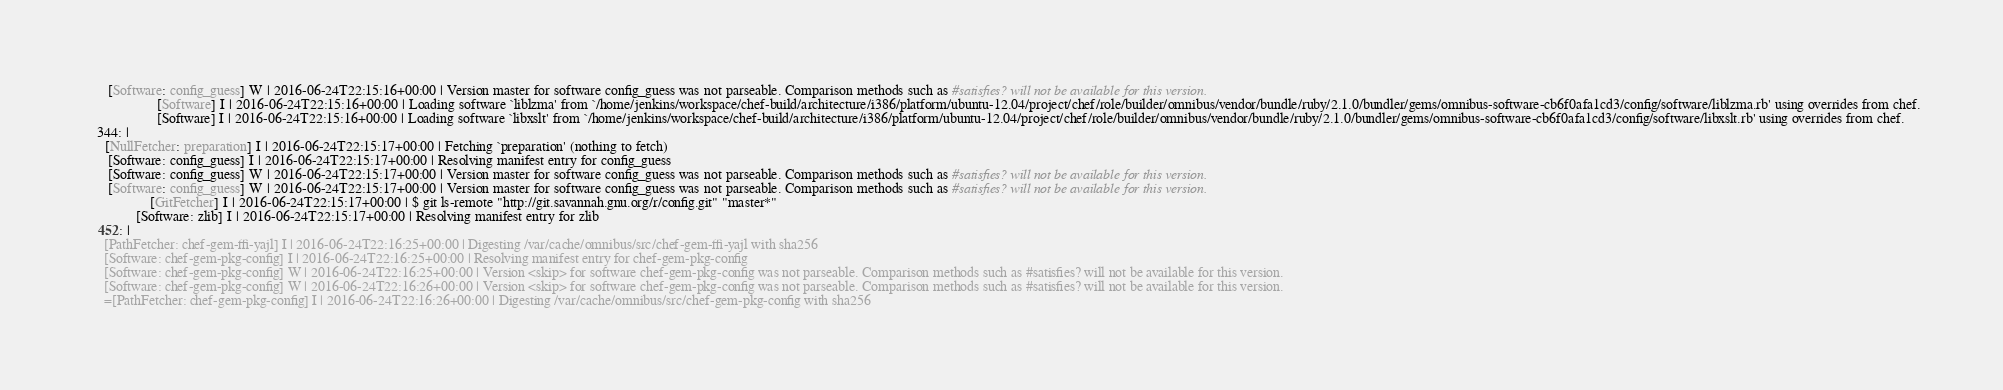<code> <loc_0><loc_0><loc_500><loc_500><_YAML_>       [Software: config_guess] W | 2016-06-24T22:15:16+00:00 | Version master for software config_guess was not parseable. Comparison methods such as #satisfies? will not be available for this version.
                     [Software] I | 2016-06-24T22:15:16+00:00 | Loading software `liblzma' from `/home/jenkins/workspace/chef-build/architecture/i386/platform/ubuntu-12.04/project/chef/role/builder/omnibus/vendor/bundle/ruby/2.1.0/bundler/gems/omnibus-software-cb6f0afa1cd3/config/software/liblzma.rb' using overrides from chef.
                     [Software] I | 2016-06-24T22:15:16+00:00 | Loading software `libxslt' from `/home/jenkins/workspace/chef-build/architecture/i386/platform/ubuntu-12.04/project/chef/role/builder/omnibus/vendor/bundle/ruby/2.1.0/bundler/gems/omnibus-software-cb6f0afa1cd3/config/software/libxslt.rb' using overrides from chef.
    344: |
      [NullFetcher: preparation] I | 2016-06-24T22:15:17+00:00 | Fetching `preparation' (nothing to fetch)
       [Software: config_guess] I | 2016-06-24T22:15:17+00:00 | Resolving manifest entry for config_guess
       [Software: config_guess] W | 2016-06-24T22:15:17+00:00 | Version master for software config_guess was not parseable. Comparison methods such as #satisfies? will not be available for this version.
       [Software: config_guess] W | 2016-06-24T22:15:17+00:00 | Version master for software config_guess was not parseable. Comparison methods such as #satisfies? will not be available for this version.
                   [GitFetcher] I | 2016-06-24T22:15:17+00:00 | $ git ls-remote "http://git.savannah.gnu.org/r/config.git" "master*"
               [Software: zlib] I | 2016-06-24T22:15:17+00:00 | Resolving manifest entry for zlib
    452: |
      [PathFetcher: chef-gem-ffi-yajl] I | 2016-06-24T22:16:25+00:00 | Digesting /var/cache/omnibus/src/chef-gem-ffi-yajl with sha256
      [Software: chef-gem-pkg-config] I | 2016-06-24T22:16:25+00:00 | Resolving manifest entry for chef-gem-pkg-config
      [Software: chef-gem-pkg-config] W | 2016-06-24T22:16:25+00:00 | Version <skip> for software chef-gem-pkg-config was not parseable. Comparison methods such as #satisfies? will not be available for this version.
      [Software: chef-gem-pkg-config] W | 2016-06-24T22:16:26+00:00 | Version <skip> for software chef-gem-pkg-config was not parseable. Comparison methods such as #satisfies? will not be available for this version.
      =[PathFetcher: chef-gem-pkg-config] I | 2016-06-24T22:16:26+00:00 | Digesting /var/cache/omnibus/src/chef-gem-pkg-config with sha256</code> 